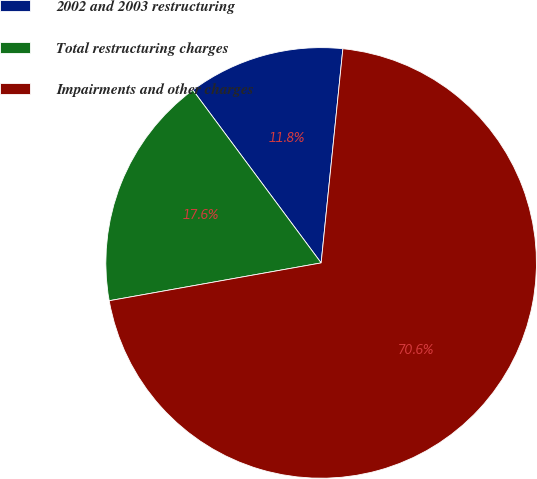<chart> <loc_0><loc_0><loc_500><loc_500><pie_chart><fcel>2002 and 2003 restructuring<fcel>Total restructuring charges<fcel>Impairments and other charges<nl><fcel>11.77%<fcel>17.65%<fcel>70.58%<nl></chart> 